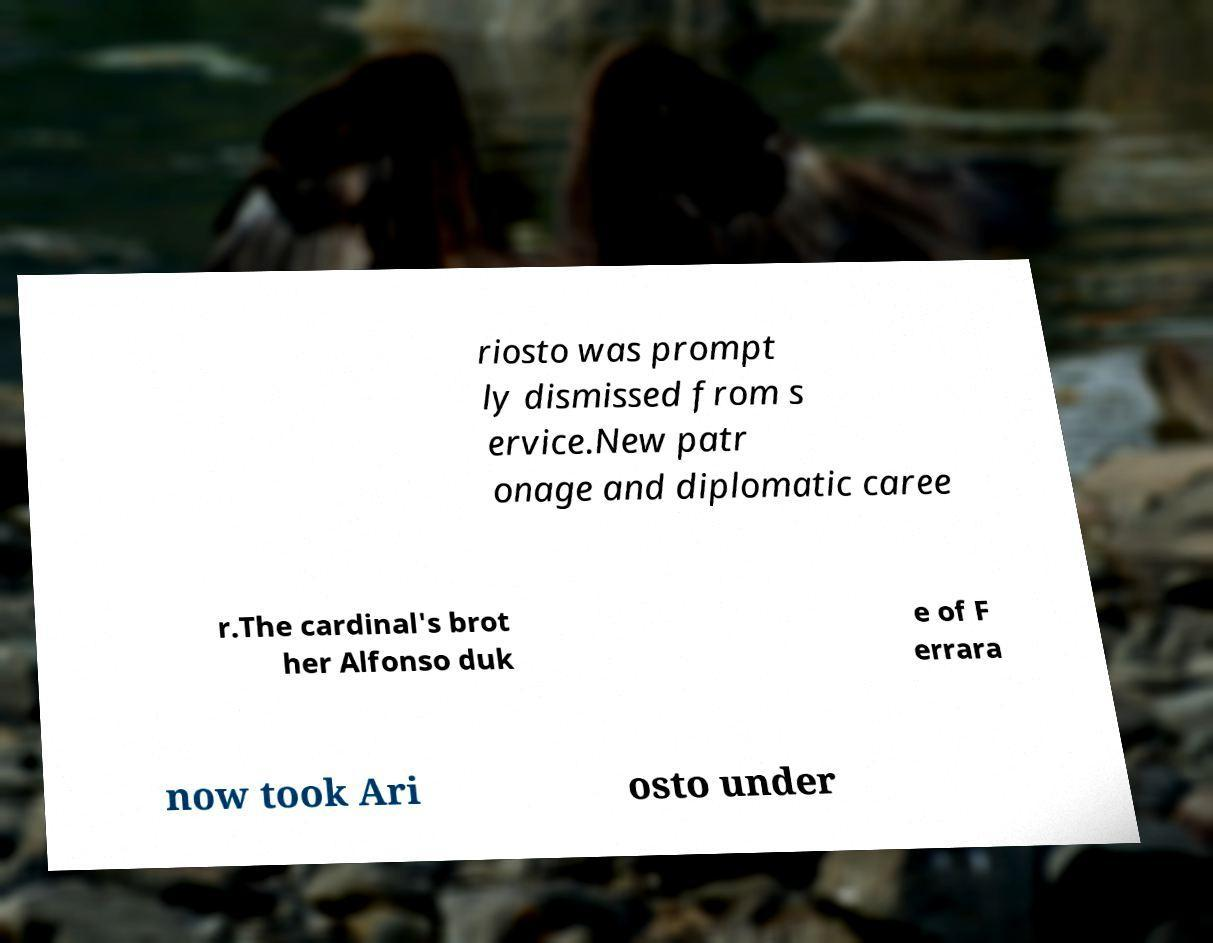I need the written content from this picture converted into text. Can you do that? riosto was prompt ly dismissed from s ervice.New patr onage and diplomatic caree r.The cardinal's brot her Alfonso duk e of F errara now took Ari osto under 